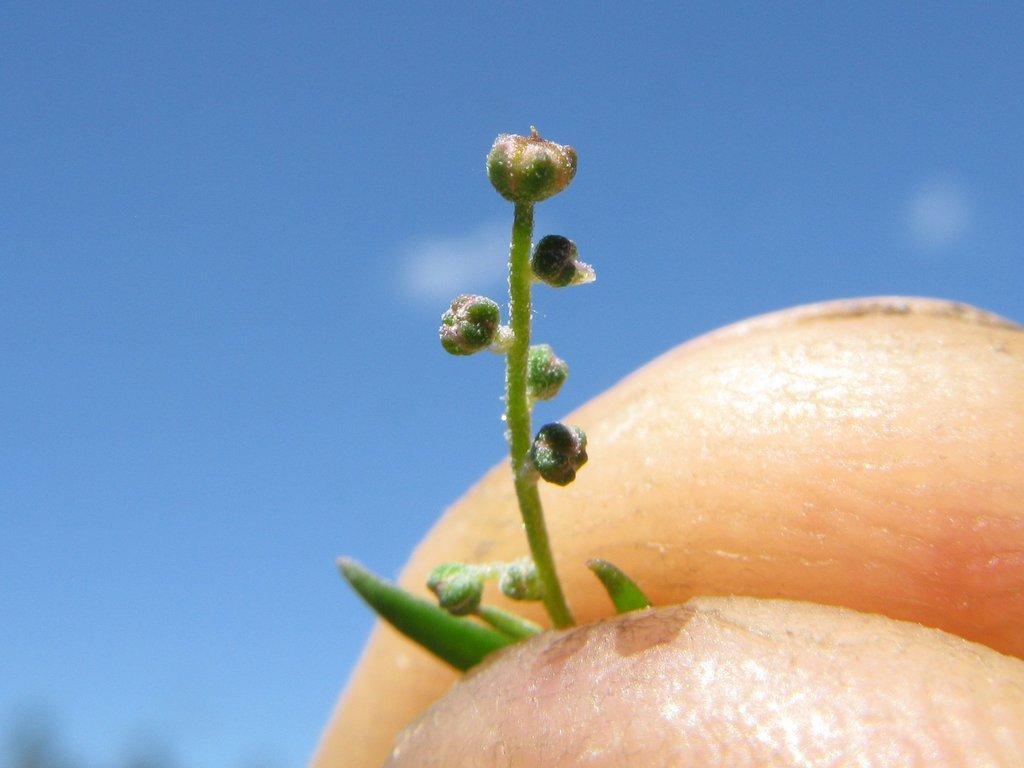Could you give a brief overview of what you see in this image? In this image we can see a person is holding a bud in the hand, there is a sky. 